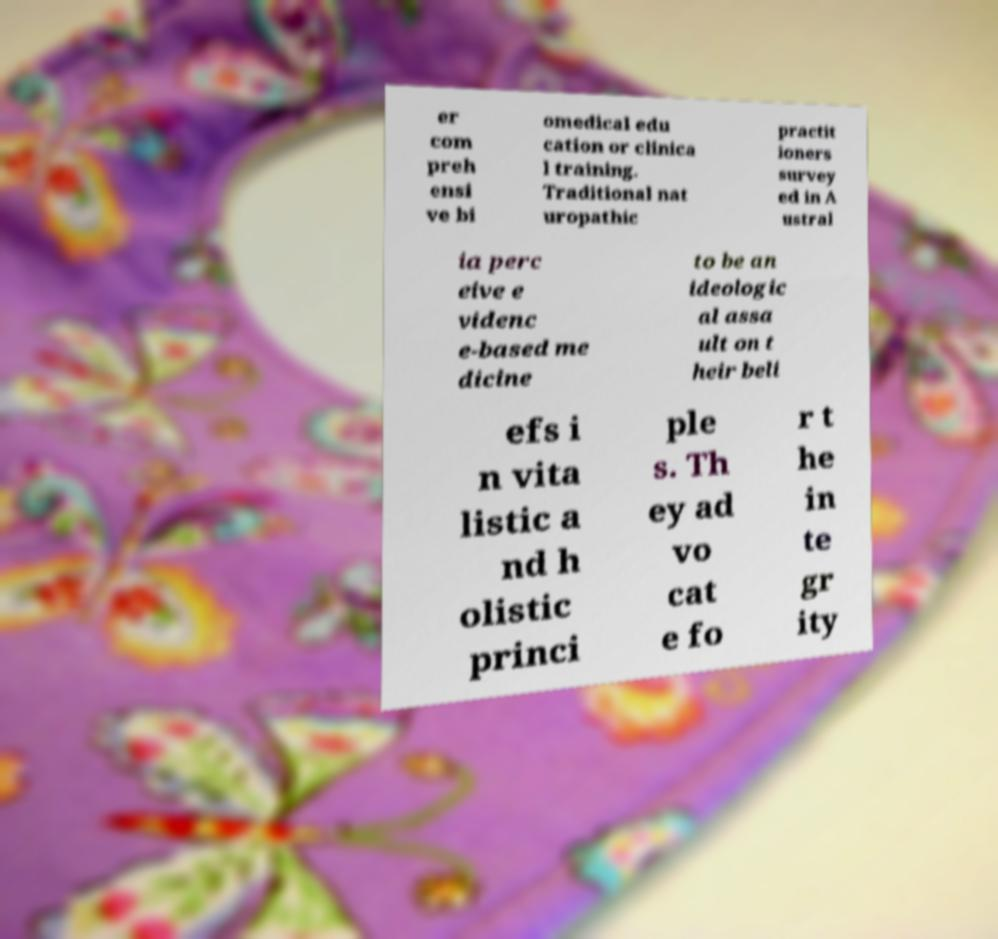Please read and relay the text visible in this image. What does it say? er com preh ensi ve bi omedical edu cation or clinica l training. Traditional nat uropathic practit ioners survey ed in A ustral ia perc eive e videnc e-based me dicine to be an ideologic al assa ult on t heir beli efs i n vita listic a nd h olistic princi ple s. Th ey ad vo cat e fo r t he in te gr ity 